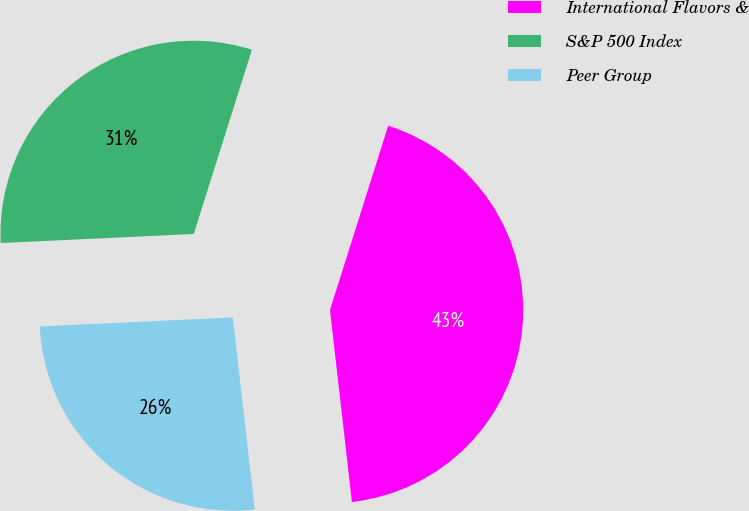Convert chart. <chart><loc_0><loc_0><loc_500><loc_500><pie_chart><fcel>International Flavors &<fcel>S&P 500 Index<fcel>Peer Group<nl><fcel>43.32%<fcel>30.62%<fcel>26.07%<nl></chart> 